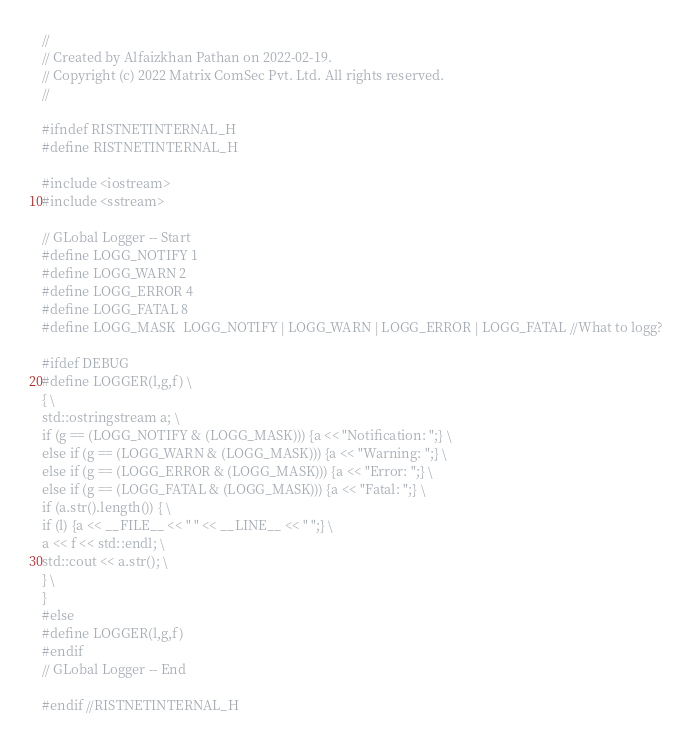Convert code to text. <code><loc_0><loc_0><loc_500><loc_500><_C_>//
// Created by Alfaizkhan Pathan on 2022-02-19.
// Copyright (c) 2022 Matrix ComSec Pvt. Ltd. All rights reserved.
//

#ifndef RISTNETINTERNAL_H
#define RISTNETINTERNAL_H

#include <iostream>
#include <sstream>

// GLobal Logger -- Start
#define LOGG_NOTIFY 1
#define LOGG_WARN 2
#define LOGG_ERROR 4
#define LOGG_FATAL 8
#define LOGG_MASK  LOGG_NOTIFY | LOGG_WARN | LOGG_ERROR | LOGG_FATAL //What to logg?

#ifdef DEBUG
#define LOGGER(l,g,f) \
{ \
std::ostringstream a; \
if (g == (LOGG_NOTIFY & (LOGG_MASK))) {a << "Notification: ";} \
else if (g == (LOGG_WARN & (LOGG_MASK))) {a << "Warning: ";} \
else if (g == (LOGG_ERROR & (LOGG_MASK))) {a << "Error: ";} \
else if (g == (LOGG_FATAL & (LOGG_MASK))) {a << "Fatal: ";} \
if (a.str().length()) { \
if (l) {a << __FILE__ << " " << __LINE__ << " ";} \
a << f << std::endl; \
std::cout << a.str(); \
} \
}
#else
#define LOGGER(l,g,f)
#endif
// GLobal Logger -- End

#endif //RISTNETINTERNAL_H
</code> 